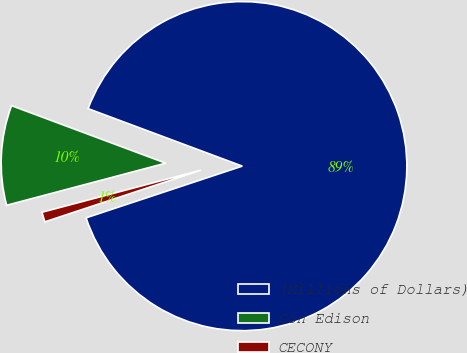<chart> <loc_0><loc_0><loc_500><loc_500><pie_chart><fcel>(Millions of Dollars)<fcel>Con Edison<fcel>CECONY<nl><fcel>89.23%<fcel>9.8%<fcel>0.97%<nl></chart> 